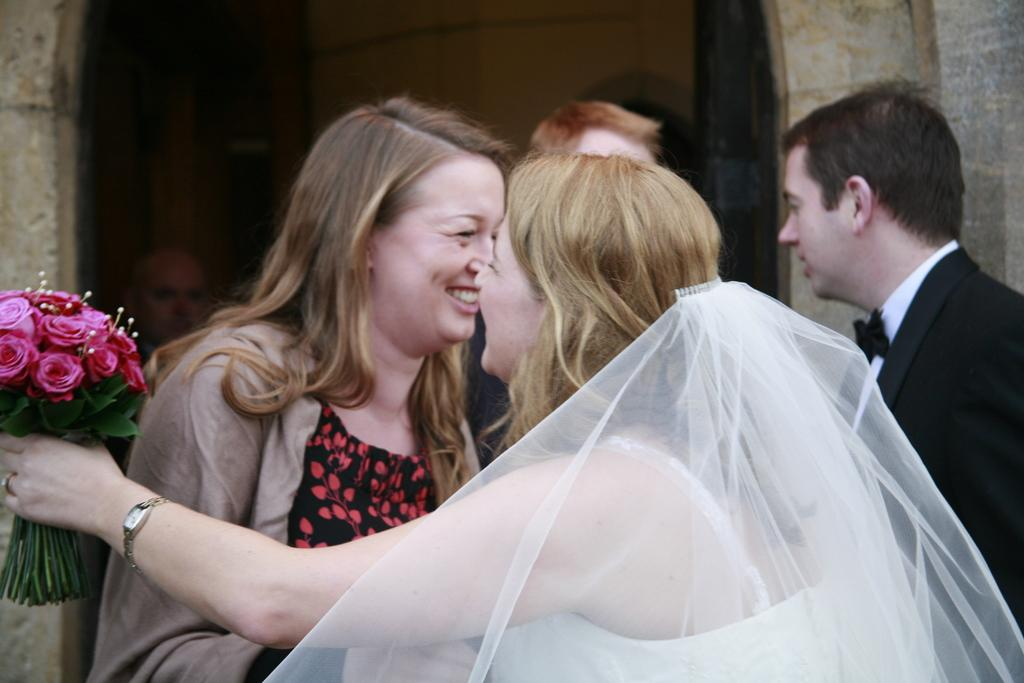What are the people in the image wearing? The people in the image are wearing clothes. Can you describe the expressions of the women in the image? Two women are smiling in the image. What type of accessory can be seen in the image? There is a flower bookmark, a finger ring, and a wrist watch in the image. What kind of structure is visible in the background of the image? There is a stone wall in the image. What type of fruit can be seen in the image? There is no fruit present in the image. What type of milk is being served in the image? There is no milk present in the image. 